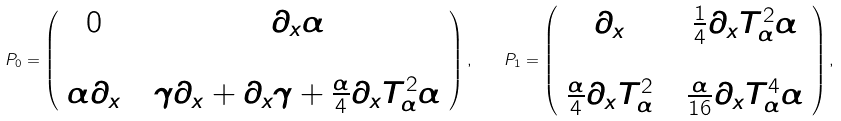<formula> <loc_0><loc_0><loc_500><loc_500>P _ { 0 } = \left ( \begin{array} { c c c } 0 & & \partial _ { x } \alpha \\ & & \\ \alpha \partial _ { x } & & \gamma \partial _ { x } + \partial _ { x } \gamma + \frac { \alpha } { 4 } \partial _ { x } T _ { \alpha } ^ { 2 } \alpha \end{array} \right ) , \quad P _ { 1 } = \left ( \begin{array} { c c c } \partial _ { x } & & \frac { 1 } { 4 } \partial _ { x } T _ { \alpha } ^ { 2 } \alpha \\ & & \\ \frac { \alpha } { 4 } \partial _ { x } T _ { \alpha } ^ { 2 } & & \frac { \alpha } { 1 6 } \partial _ { x } T _ { \alpha } ^ { 4 } \alpha \end{array} \right ) ,</formula> 